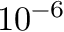Convert formula to latex. <formula><loc_0><loc_0><loc_500><loc_500>1 0 ^ { - 6 }</formula> 